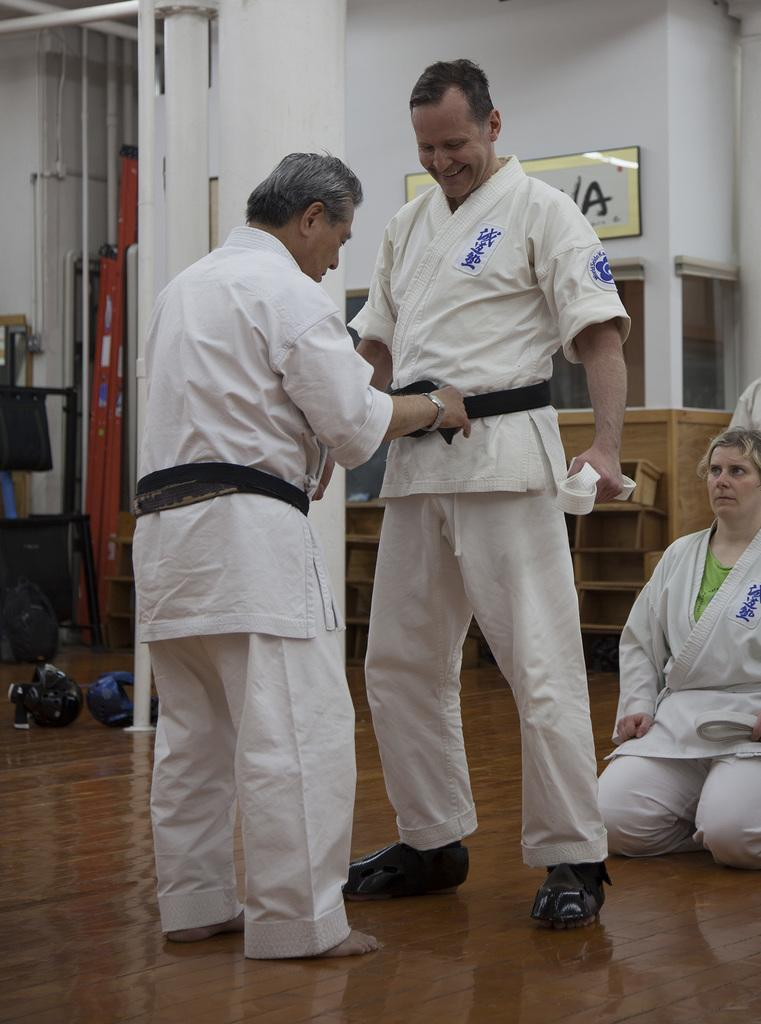<image>
Relay a brief, clear account of the picture shown. A short, Asian man is securing a black belt on a man in a Karate uniform, in front of a sign with the last letter being A. 